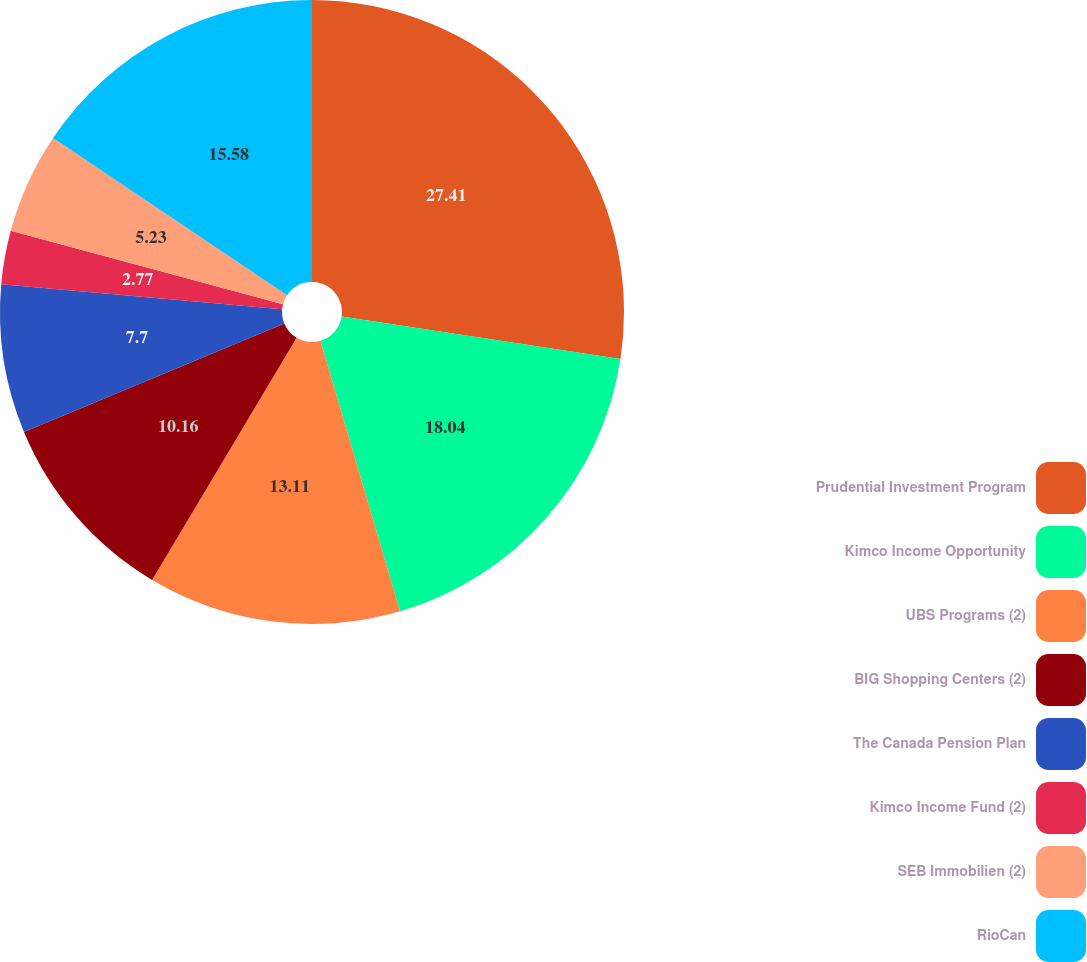Convert chart to OTSL. <chart><loc_0><loc_0><loc_500><loc_500><pie_chart><fcel>Prudential Investment Program<fcel>Kimco Income Opportunity<fcel>UBS Programs (2)<fcel>BIG Shopping Centers (2)<fcel>The Canada Pension Plan<fcel>Kimco Income Fund (2)<fcel>SEB Immobilien (2)<fcel>RioCan<nl><fcel>27.41%<fcel>18.04%<fcel>13.11%<fcel>10.16%<fcel>7.7%<fcel>2.77%<fcel>5.23%<fcel>15.58%<nl></chart> 